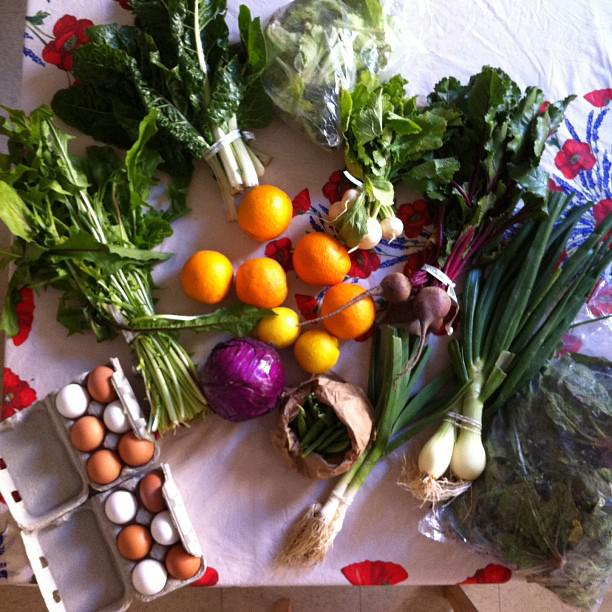Question: what are on the floor?
Choices:
A. Linoleum.
B. Wood.
C. Carpet.
D. Tiles.
Answer with the letter. Answer: D Question: what are these things?
Choices:
A. Rings.
B. Food.
C. Stars.
D. Planets.
Answer with the letter. Answer: B Question: what is the the carton?
Choices:
A. Milk.
B. A lost child.
C. Water.
D. Eggs.
Answer with the letter. Answer: D Question: how many colors of eggs are there?
Choices:
A. 3.
B. 2.
C. 1.
D. 22.
Answer with the letter. Answer: B Question: what kind of bag holds produce?
Choices:
A. Paper.
B. Cotton.
C. Polyester.
D. Plastic.
Answer with the letter. Answer: D Question: where was the the photo taken?
Choices:
A. Above a table.
B. The house.
C. Your house.
D. The yard.
Answer with the letter. Answer: A Question: what is this a picture of?
Choices:
A. Food.
B. Wine.
C. Flowers.
D. Dishes.
Answer with the letter. Answer: A Question: what is mostly in this picture?
Choices:
A. Fresh meat.
B. Fresh fruits and vegetables.
C. Corn.
D. Potatoes.
Answer with the letter. Answer: B Question: what color is the head of cabbage?
Choices:
A. Green.
B. Red.
C. Purple.
D. White.
Answer with the letter. Answer: C Question: how are the greens contained?
Choices:
A. In a bag.
B. In bunches.
C. In a basket.
D. Rubberbands.
Answer with the letter. Answer: B Question: what is printed on the cloth?
Choices:
A. Nothing.
B. Birds.
C. Cars.
D. Red flowers.
Answer with the letter. Answer: D Question: what is in the brown, paper bag?
Choices:
A. Red produce.
B. Yellow produce.
C. Green produce.
D. Orange produce.
Answer with the letter. Answer: C Question: what color are the eggs?
Choices:
A. Yellow.
B. Blue.
C. Green.
D. Brown and white.
Answer with the letter. Answer: D Question: how are the cartons of eggs displayed?
Choices:
A. The carton is closed.
B. The carton is open.
C. A hole is cut in the carton.
D. The carton is cut in half.
Answer with the letter. Answer: B Question: what vegetables are bound in bunches?
Choices:
A. The lettuce, radishes, and cucumbers.
B. The carrots, potatoes, and squash.
C. The corn, asparagus, and tomatoes.
D. The kale, spinach, and onions.
Answer with the letter. Answer: D Question: what type of vegetable is the most predominant?
Choices:
A. Spinach.
B. Broccoli.
C. Leafy greens.
D. Cabbage.
Answer with the letter. Answer: C Question: what fruit is in the middle?
Choices:
A. Apples.
B. Peaches.
C. Oranges.
D. Bananas.
Answer with the letter. Answer: C Question: what is tied around the bunch of onions?
Choices:
A. A rubber band.
B. A sticker.
C. A ribbon.
D. A string.
Answer with the letter. Answer: D 